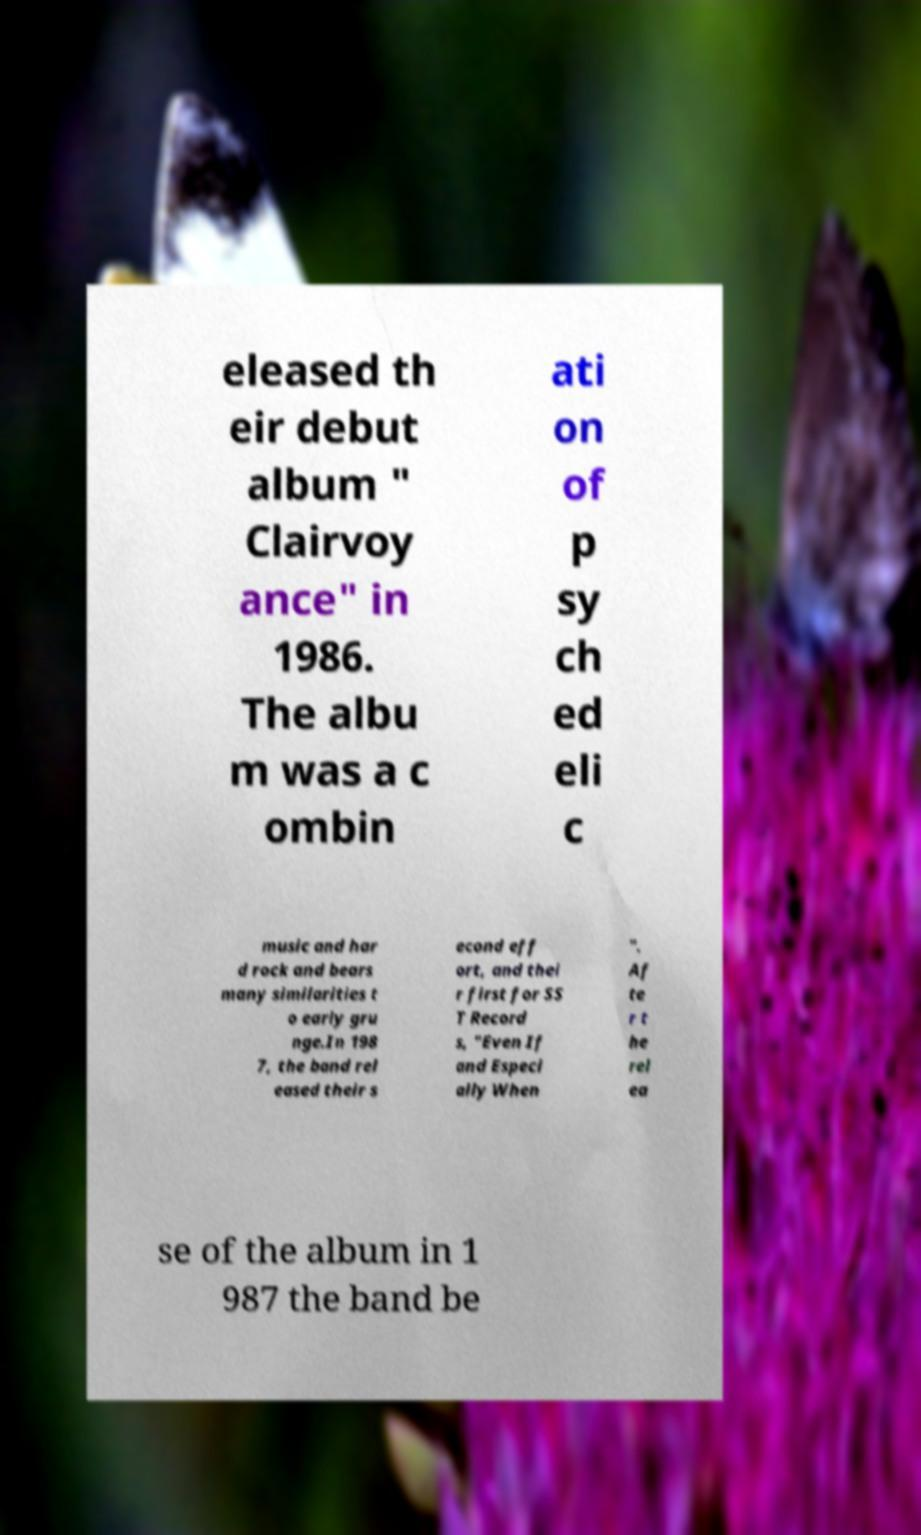There's text embedded in this image that I need extracted. Can you transcribe it verbatim? eleased th eir debut album " Clairvoy ance" in 1986. The albu m was a c ombin ati on of p sy ch ed eli c music and har d rock and bears many similarities t o early gru nge.In 198 7, the band rel eased their s econd eff ort, and thei r first for SS T Record s, "Even If and Especi ally When ". Af te r t he rel ea se of the album in 1 987 the band be 